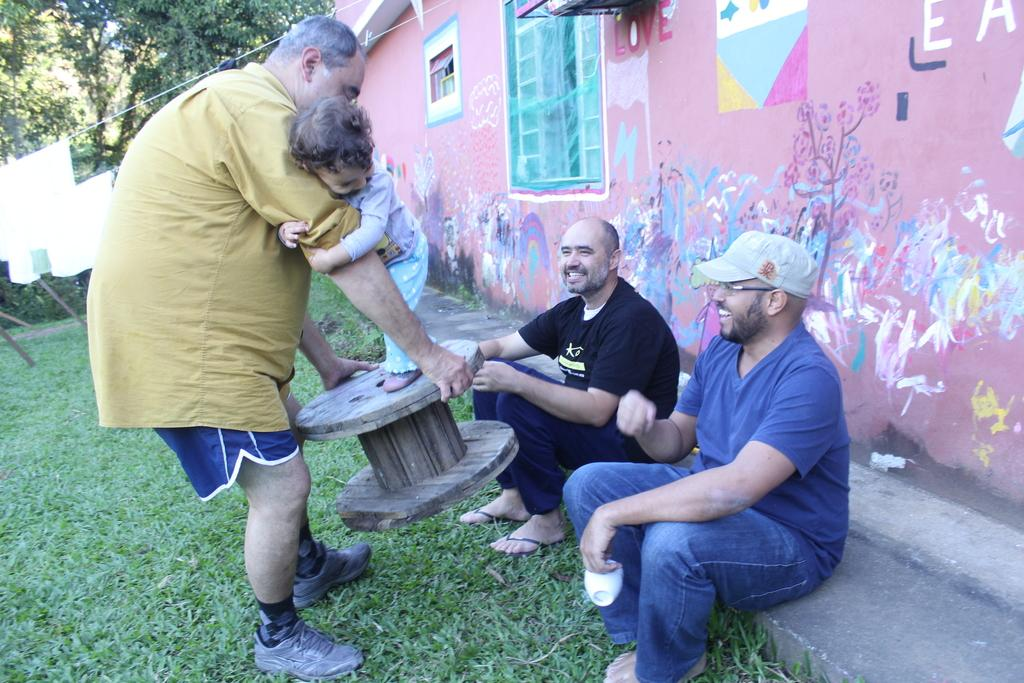How many people are in the image? There are four people in the image: three men and a kid. What is the facial expression of the people in the image? All the people in the image are smiling. What type of surface is visible in the image? There is grass in the image. What architectural features can be seen in the background of the image? There is a wall and a window in the background of the image. What type of artwork is present in the background of the image? There is a painting in the background of the image. What type of vegetation is visible in the background of the image? There are trees in the background of the image. What type of nail is being hammered into the tree in the image? There is no nail being hammered into the tree in the image; there are no nails or hammering activity depicted. 